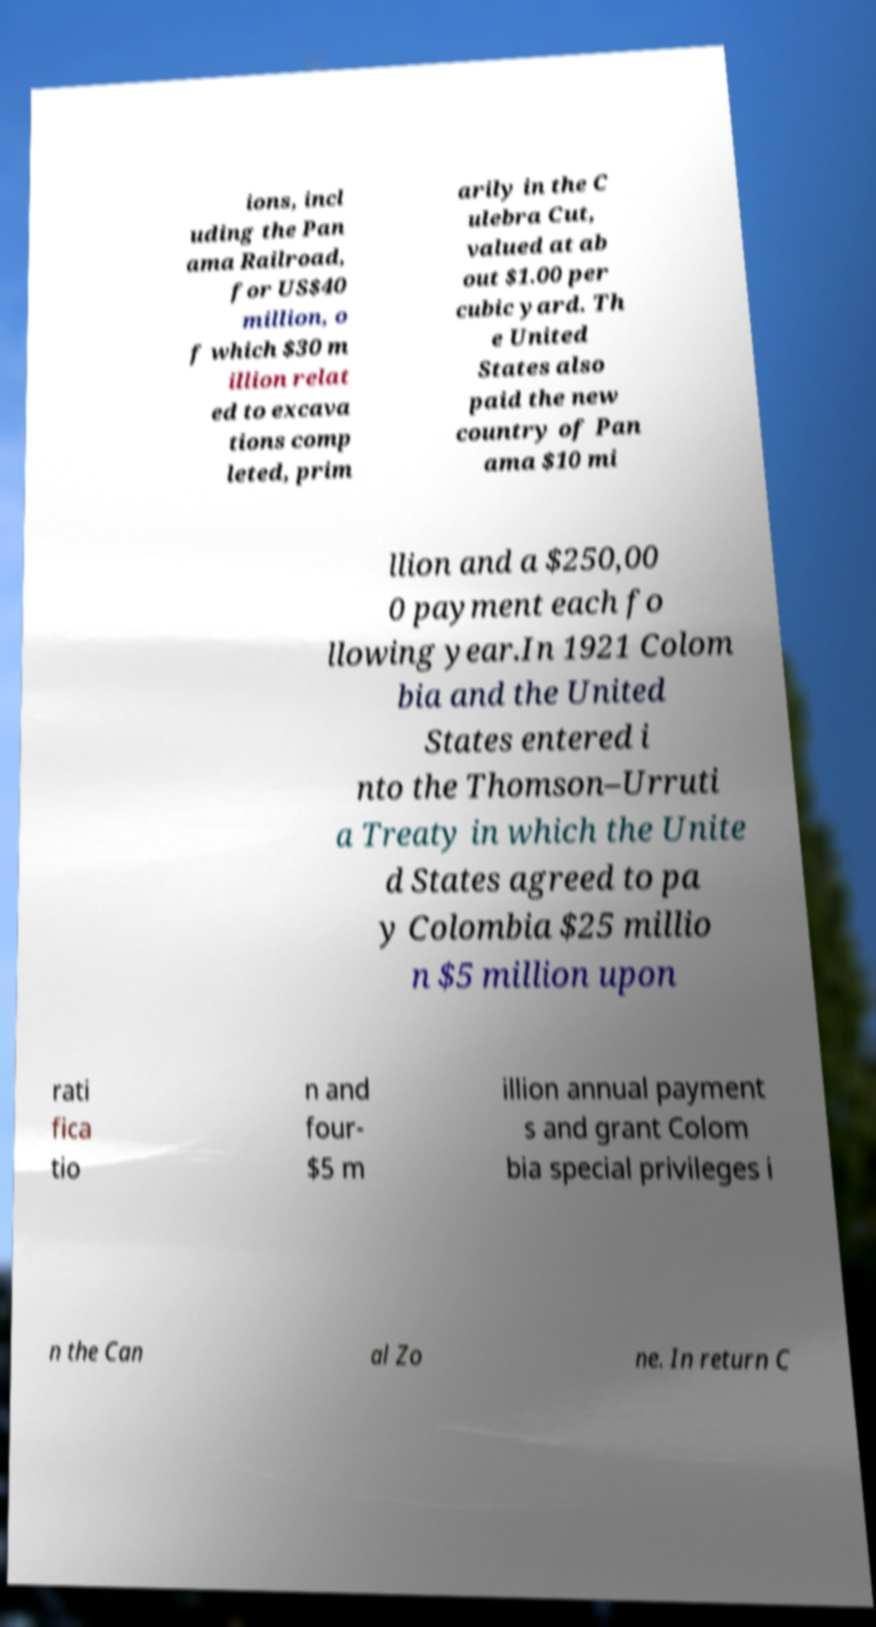Please identify and transcribe the text found in this image. ions, incl uding the Pan ama Railroad, for US$40 million, o f which $30 m illion relat ed to excava tions comp leted, prim arily in the C ulebra Cut, valued at ab out $1.00 per cubic yard. Th e United States also paid the new country of Pan ama $10 mi llion and a $250,00 0 payment each fo llowing year.In 1921 Colom bia and the United States entered i nto the Thomson–Urruti a Treaty in which the Unite d States agreed to pa y Colombia $25 millio n $5 million upon rati fica tio n and four- $5 m illion annual payment s and grant Colom bia special privileges i n the Can al Zo ne. In return C 